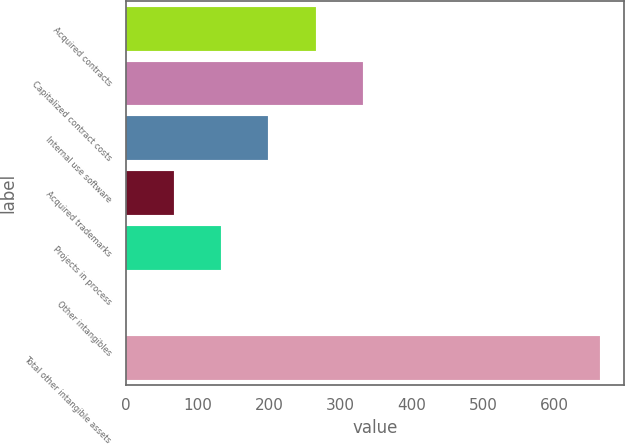<chart> <loc_0><loc_0><loc_500><loc_500><bar_chart><fcel>Acquired contracts<fcel>Capitalized contract costs<fcel>Internal use software<fcel>Acquired trademarks<fcel>Projects in process<fcel>Other intangibles<fcel>Total other intangible assets<nl><fcel>265.86<fcel>332.25<fcel>199.47<fcel>66.69<fcel>133.08<fcel>0.3<fcel>664.2<nl></chart> 